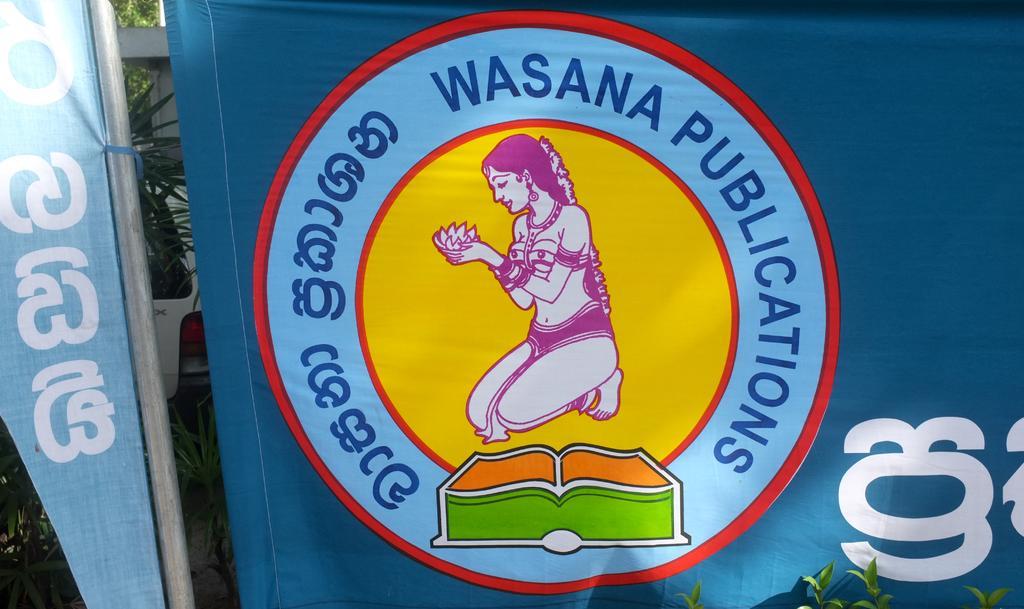How would you summarize this image in a sentence or two? In this picture we can see a logo and some text, in the background there are some plants, we can see leaves at the right bottom. 